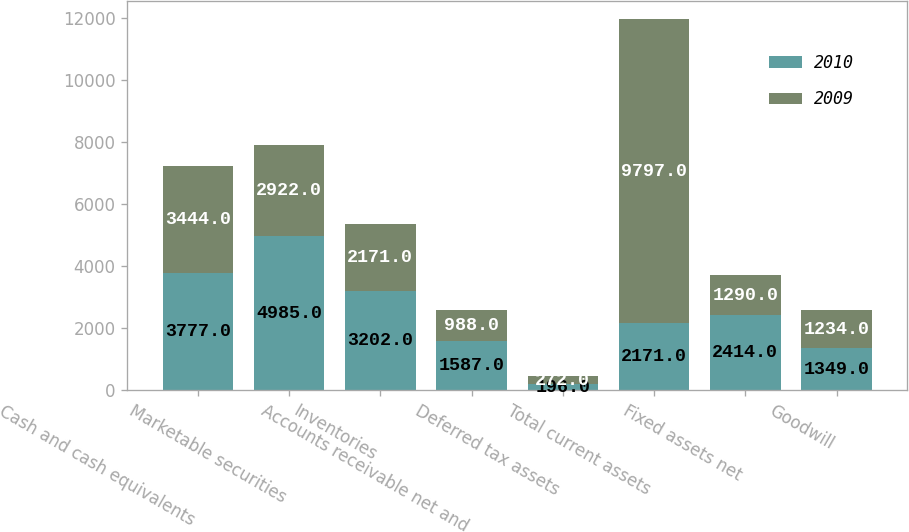<chart> <loc_0><loc_0><loc_500><loc_500><stacked_bar_chart><ecel><fcel>Cash and cash equivalents<fcel>Marketable securities<fcel>Inventories<fcel>Accounts receivable net and<fcel>Deferred tax assets<fcel>Total current assets<fcel>Fixed assets net<fcel>Goodwill<nl><fcel>2010<fcel>3777<fcel>4985<fcel>3202<fcel>1587<fcel>196<fcel>2171<fcel>2414<fcel>1349<nl><fcel>2009<fcel>3444<fcel>2922<fcel>2171<fcel>988<fcel>272<fcel>9797<fcel>1290<fcel>1234<nl></chart> 